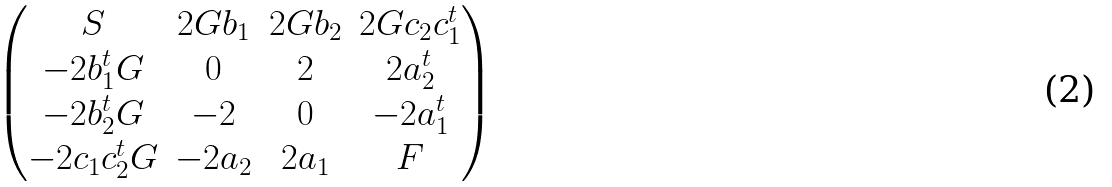Convert formula to latex. <formula><loc_0><loc_0><loc_500><loc_500>\begin{pmatrix} S & 2 G b _ { 1 } & 2 G b _ { 2 } & 2 G c _ { 2 } c _ { 1 } ^ { t } \\ - 2 b _ { 1 } ^ { t } G & 0 & 2 & 2 a _ { 2 } ^ { t } \\ - 2 b _ { 2 } ^ { t } G & - 2 & 0 & - 2 a _ { 1 } ^ { t } \\ - 2 c _ { 1 } c _ { 2 } ^ { t } G & - 2 a _ { 2 } & 2 a _ { 1 } & F \\ \end{pmatrix}</formula> 